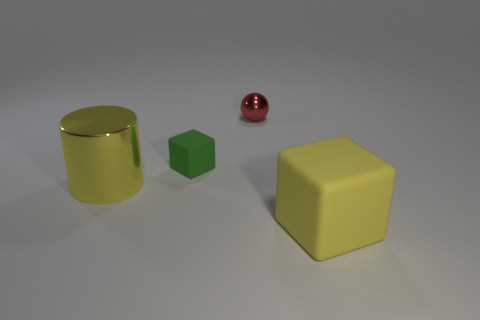Add 4 yellow blocks. How many objects exist? 8 Subtract all spheres. How many objects are left? 3 Subtract all big purple matte objects. Subtract all large yellow metal objects. How many objects are left? 3 Add 4 large yellow metallic things. How many large yellow metallic things are left? 5 Add 1 small blocks. How many small blocks exist? 2 Subtract 0 brown cylinders. How many objects are left? 4 